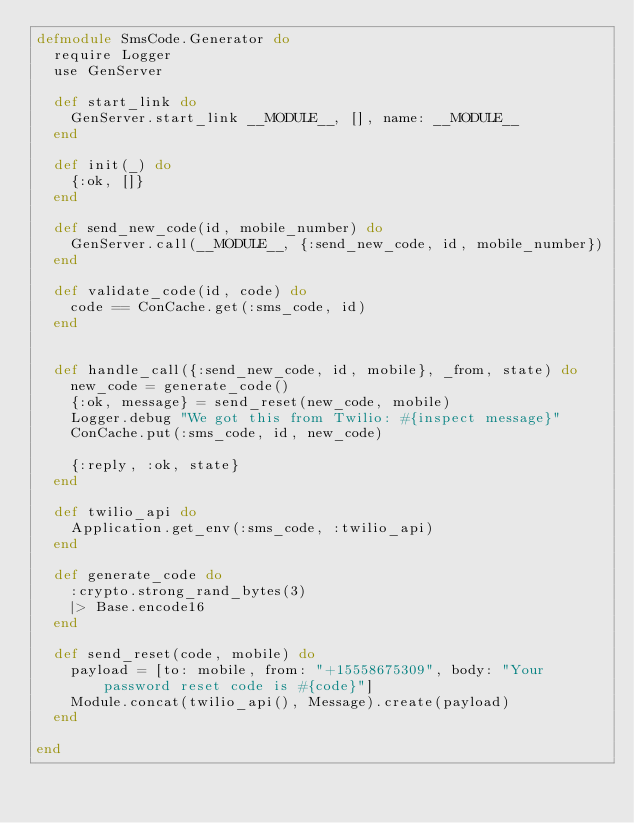<code> <loc_0><loc_0><loc_500><loc_500><_Elixir_>defmodule SmsCode.Generator do
  require Logger
  use GenServer

  def start_link do
    GenServer.start_link __MODULE__, [], name: __MODULE__
  end

  def init(_) do
    {:ok, []}
  end

  def send_new_code(id, mobile_number) do
    GenServer.call(__MODULE__, {:send_new_code, id, mobile_number})
  end

  def validate_code(id, code) do
    code == ConCache.get(:sms_code, id)
  end


  def handle_call({:send_new_code, id, mobile}, _from, state) do
    new_code = generate_code()
    {:ok, message} = send_reset(new_code, mobile)
    Logger.debug "We got this from Twilio: #{inspect message}"
    ConCache.put(:sms_code, id, new_code)

    {:reply, :ok, state}
  end

  def twilio_api do
    Application.get_env(:sms_code, :twilio_api)
  end

  def generate_code do
    :crypto.strong_rand_bytes(3)
    |> Base.encode16
  end

  def send_reset(code, mobile) do
    payload = [to: mobile, from: "+15558675309", body: "Your password reset code is #{code}"]
    Module.concat(twilio_api(), Message).create(payload)
  end

end
</code> 